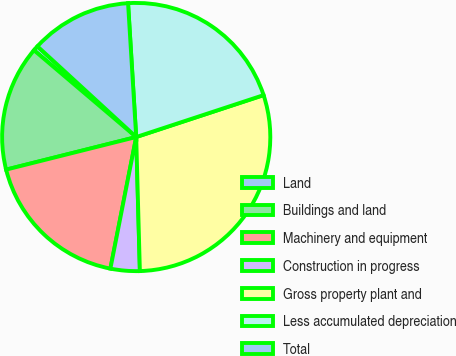<chart> <loc_0><loc_0><loc_500><loc_500><pie_chart><fcel>Land<fcel>Buildings and land<fcel>Machinery and equipment<fcel>Construction in progress<fcel>Gross property plant and<fcel>Less accumulated depreciation<fcel>Total<nl><fcel>0.62%<fcel>15.11%<fcel>18.01%<fcel>3.52%<fcel>29.62%<fcel>20.91%<fcel>12.21%<nl></chart> 